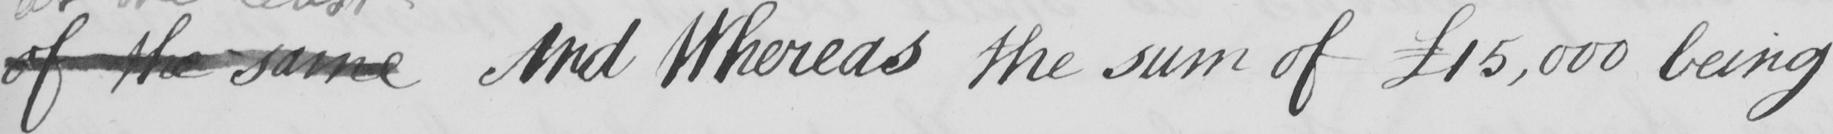Please provide the text content of this handwritten line. of the same And Whereas the sum of  £15,000 being 